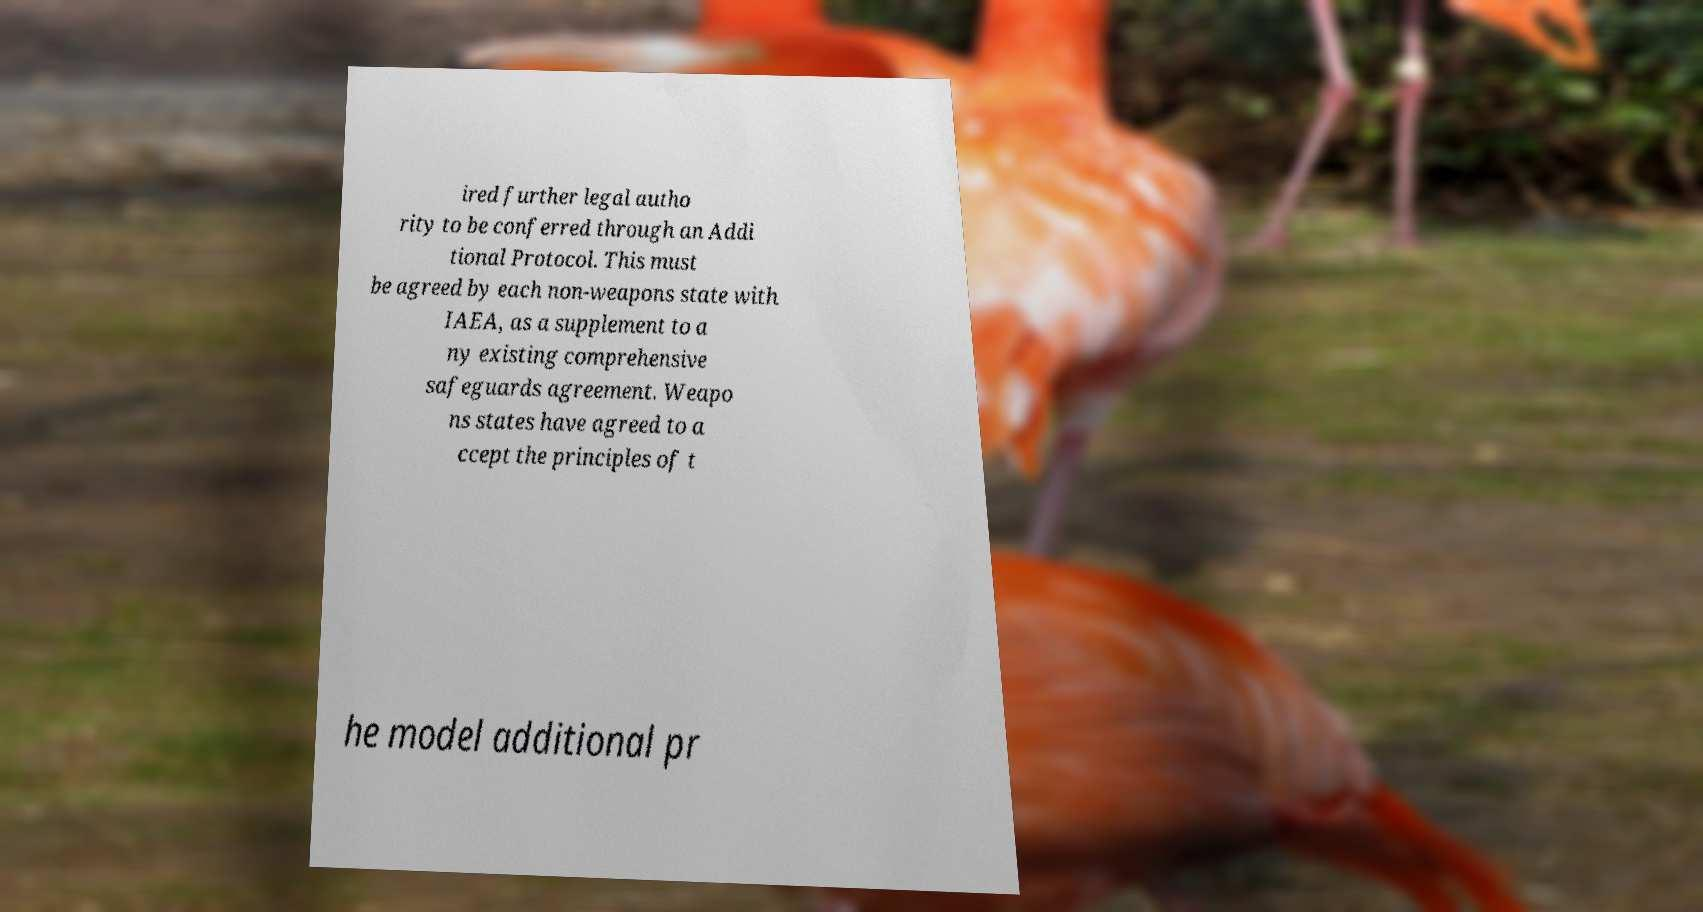Could you extract and type out the text from this image? ired further legal autho rity to be conferred through an Addi tional Protocol. This must be agreed by each non-weapons state with IAEA, as a supplement to a ny existing comprehensive safeguards agreement. Weapo ns states have agreed to a ccept the principles of t he model additional pr 